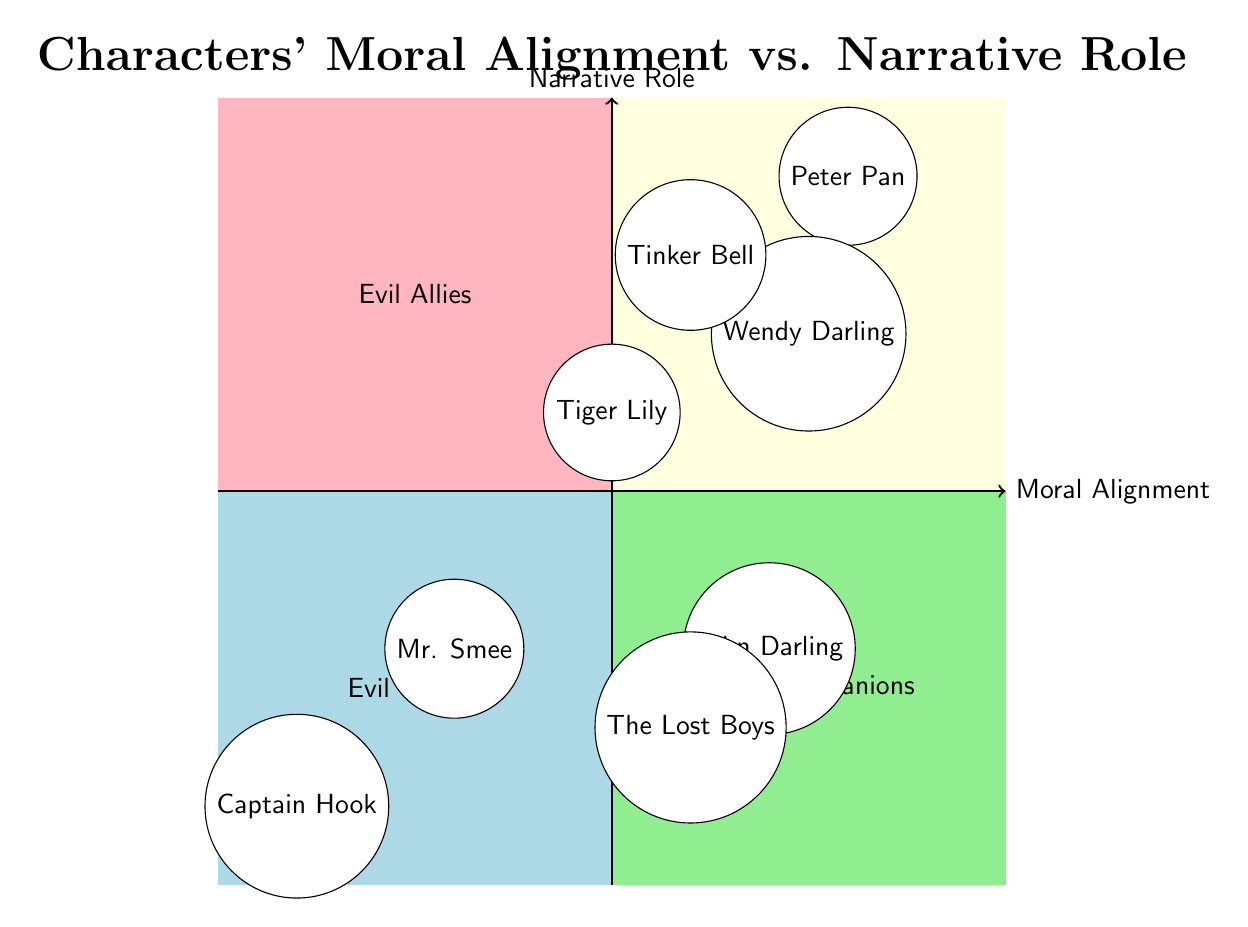What is the narrative role of Peter Pan? According to the diagram, Peter Pan is positioned in the "Good Heroes" quadrant, where the narrative role indicated is "Hero."
Answer: Hero How many characters are categorized as "Good"? From the diagram, the characters in the "Good" category are Peter Pan, Wendy Darling, John Darling, and The Lost Boys, totaling four characters.
Answer: 4 Which character is both chaotic in moral alignment and has a trickster role? Tinker Bell is located in the "Chaotic Good" section of the diagram and labeled as a "Trickster."
Answer: Tinker Bell What is the moral alignment of Captain Hook? Captain Hook is positioned in the "Evil Villains" quadrant, explicitly marked with the moral alignment of "Evil."
Answer: Evil How many characters have a narrative role as "Companion"? The diagram displays only one character, John Darling, in the "Good Companions" quadrant, indicating that he holds this narrative role.
Answer: 1 Which quadrant contains characters with a "Neutral Good" moral alignment? The "Neutral Good" characters, John Darling and The Lost Boys, are found in the "Good Companions" quadrant alongside the zone labeled for supports.
Answer: Good Companions Who is labeled as a "Villain" in the diagram? The character designated as a "Villain" in the diagram is Captain Hook, placed in the "Evil Villains" quadrant.
Answer: Captain Hook Is there a character who is both an ally and has a chaotic alignment? Yes, Tiger Lily fits this category as she is located in the "Chaotic Neutral" section and is labeled as an "Ally."
Answer: Tiger Lily What are the narrative roles present in the "Evil Villains" quadrant? Within the "Evil Villains" quadrant, the only narrative role depicted is "Villain," corresponding to Captain Hook in the diagram.
Answer: Villain 